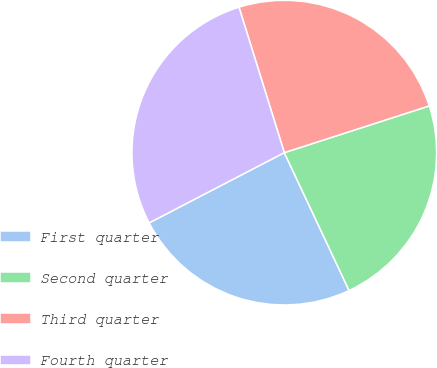Convert chart. <chart><loc_0><loc_0><loc_500><loc_500><pie_chart><fcel>First quarter<fcel>Second quarter<fcel>Third quarter<fcel>Fourth quarter<nl><fcel>24.36%<fcel>22.97%<fcel>24.84%<fcel>27.82%<nl></chart> 